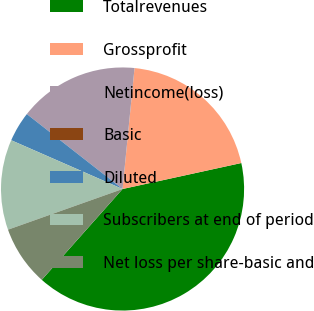<chart> <loc_0><loc_0><loc_500><loc_500><pie_chart><fcel>Totalrevenues<fcel>Grossprofit<fcel>Netincome(loss)<fcel>Basic<fcel>Diluted<fcel>Subscribers at end of period<fcel>Net loss per share-basic and<nl><fcel>40.0%<fcel>20.0%<fcel>16.0%<fcel>0.0%<fcel>4.0%<fcel>12.0%<fcel>8.0%<nl></chart> 